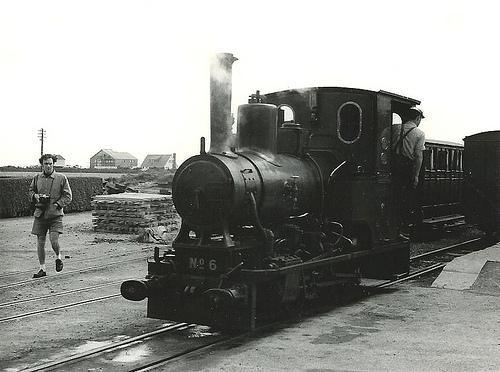Question: what color is the photo?
Choices:
A. Red.
B. Green.
C. Blue.
D. Black and white.
Answer with the letter. Answer: D Question: what is the train on?
Choices:
A. It's side.
B. The tracks.
C. A bridge.
D. A train lift.
Answer with the letter. Answer: B Question: what number train is it?
Choices:
A. 5.
B. 6.
C. 3.
D. 7.
Answer with the letter. Answer: B Question: who is in the photo?
Choices:
A. A woman.
B. A boy.
C. A guy.
D. A girl.
Answer with the letter. Answer: C 